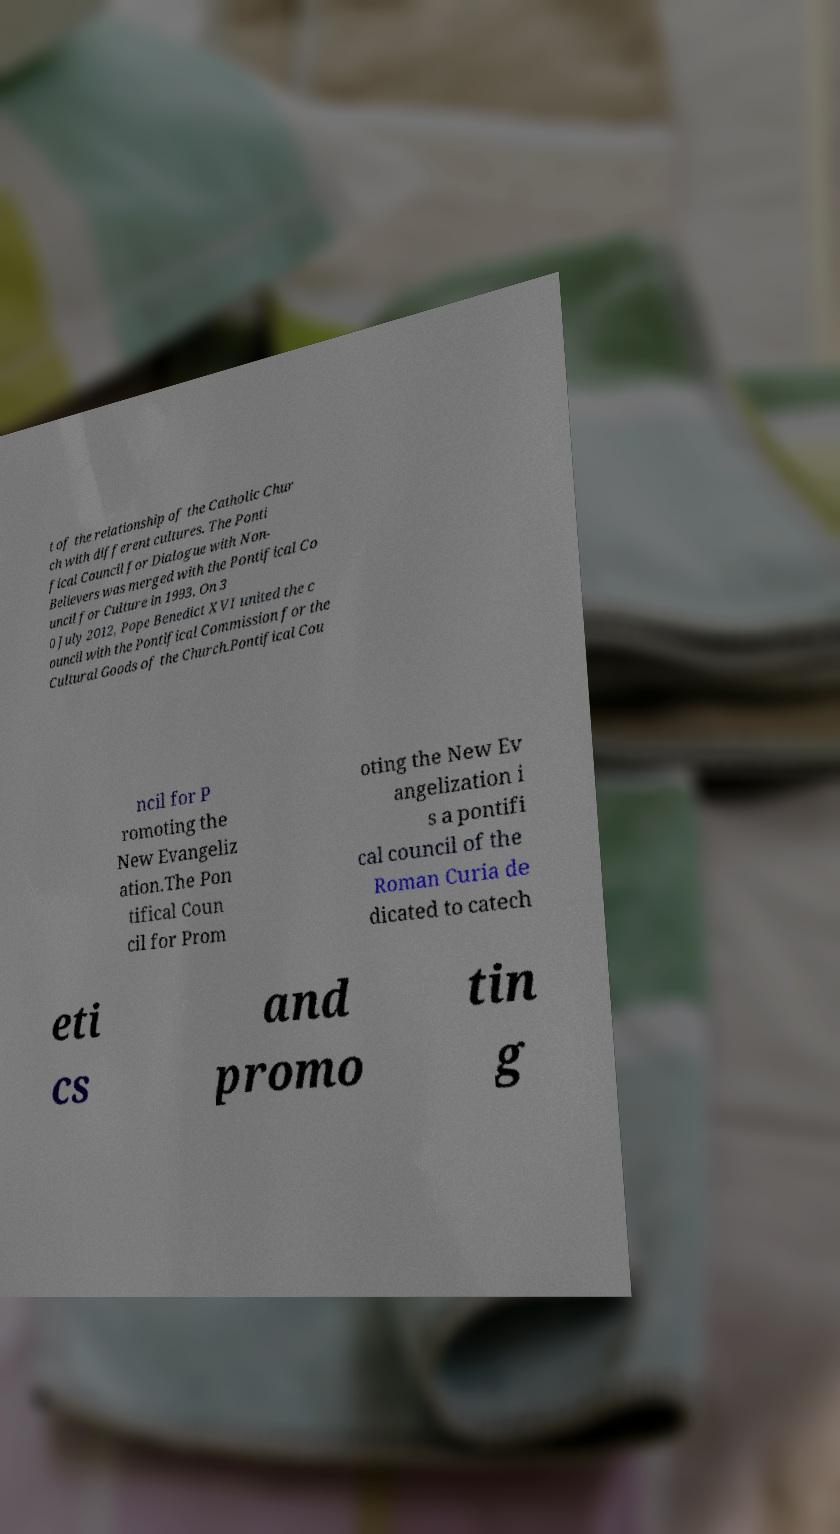Could you assist in decoding the text presented in this image and type it out clearly? t of the relationship of the Catholic Chur ch with different cultures. The Ponti fical Council for Dialogue with Non- Believers was merged with the Pontifical Co uncil for Culture in 1993. On 3 0 July 2012, Pope Benedict XVI united the c ouncil with the Pontifical Commission for the Cultural Goods of the Church.Pontifical Cou ncil for P romoting the New Evangeliz ation.The Pon tifical Coun cil for Prom oting the New Ev angelization i s a pontifi cal council of the Roman Curia de dicated to catech eti cs and promo tin g 